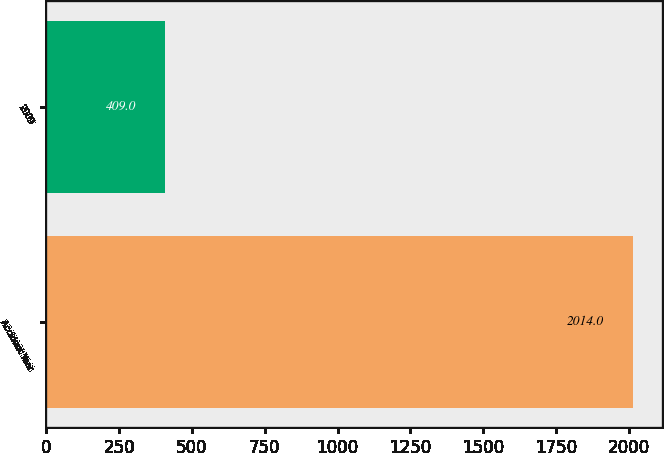<chart> <loc_0><loc_0><loc_500><loc_500><bar_chart><fcel>Accident Year<fcel>2009<nl><fcel>2014<fcel>409<nl></chart> 